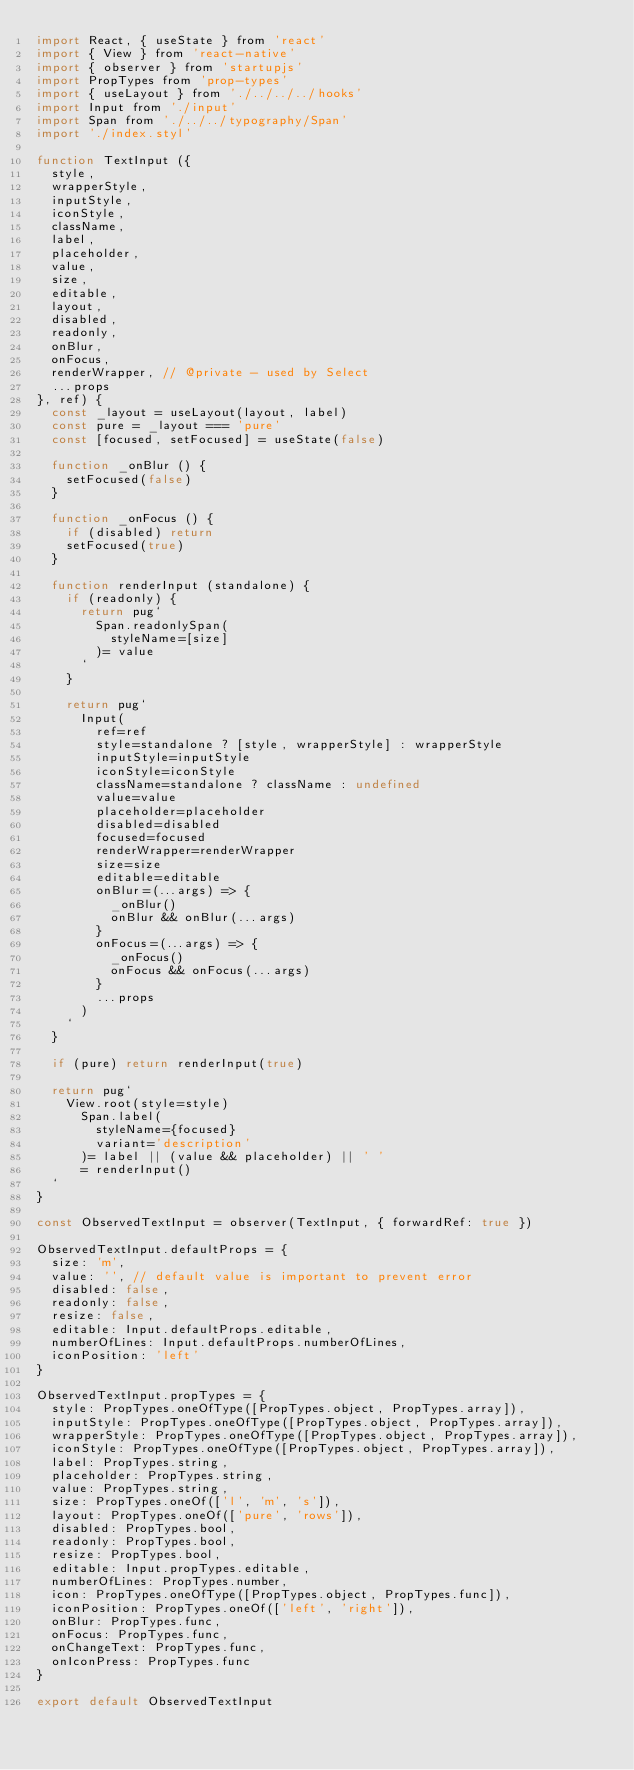<code> <loc_0><loc_0><loc_500><loc_500><_JavaScript_>import React, { useState } from 'react'
import { View } from 'react-native'
import { observer } from 'startupjs'
import PropTypes from 'prop-types'
import { useLayout } from './../../../hooks'
import Input from './input'
import Span from './../../typography/Span'
import './index.styl'

function TextInput ({
  style,
  wrapperStyle,
  inputStyle,
  iconStyle,
  className,
  label,
  placeholder,
  value,
  size,
  editable,
  layout,
  disabled,
  readonly,
  onBlur,
  onFocus,
  renderWrapper, // @private - used by Select
  ...props
}, ref) {
  const _layout = useLayout(layout, label)
  const pure = _layout === 'pure'
  const [focused, setFocused] = useState(false)

  function _onBlur () {
    setFocused(false)
  }

  function _onFocus () {
    if (disabled) return
    setFocused(true)
  }

  function renderInput (standalone) {
    if (readonly) {
      return pug`
        Span.readonlySpan(
          styleName=[size]
        )= value
      `
    }

    return pug`
      Input(
        ref=ref
        style=standalone ? [style, wrapperStyle] : wrapperStyle
        inputStyle=inputStyle
        iconStyle=iconStyle
        className=standalone ? className : undefined
        value=value
        placeholder=placeholder
        disabled=disabled
        focused=focused
        renderWrapper=renderWrapper
        size=size
        editable=editable
        onBlur=(...args) => {
          _onBlur()
          onBlur && onBlur(...args)
        }
        onFocus=(...args) => {
          _onFocus()
          onFocus && onFocus(...args)
        }
        ...props
      )
    `
  }

  if (pure) return renderInput(true)

  return pug`
    View.root(style=style)
      Span.label(
        styleName={focused}
        variant='description'
      )= label || (value && placeholder) || ' '
      = renderInput()
  `
}

const ObservedTextInput = observer(TextInput, { forwardRef: true })

ObservedTextInput.defaultProps = {
  size: 'm',
  value: '', // default value is important to prevent error
  disabled: false,
  readonly: false,
  resize: false,
  editable: Input.defaultProps.editable,
  numberOfLines: Input.defaultProps.numberOfLines,
  iconPosition: 'left'
}

ObservedTextInput.propTypes = {
  style: PropTypes.oneOfType([PropTypes.object, PropTypes.array]),
  inputStyle: PropTypes.oneOfType([PropTypes.object, PropTypes.array]),
  wrapperStyle: PropTypes.oneOfType([PropTypes.object, PropTypes.array]),
  iconStyle: PropTypes.oneOfType([PropTypes.object, PropTypes.array]),
  label: PropTypes.string,
  placeholder: PropTypes.string,
  value: PropTypes.string,
  size: PropTypes.oneOf(['l', 'm', 's']),
  layout: PropTypes.oneOf(['pure', 'rows']),
  disabled: PropTypes.bool,
  readonly: PropTypes.bool,
  resize: PropTypes.bool,
  editable: Input.propTypes.editable,
  numberOfLines: PropTypes.number,
  icon: PropTypes.oneOfType([PropTypes.object, PropTypes.func]),
  iconPosition: PropTypes.oneOf(['left', 'right']),
  onBlur: PropTypes.func,
  onFocus: PropTypes.func,
  onChangeText: PropTypes.func,
  onIconPress: PropTypes.func
}

export default ObservedTextInput
</code> 